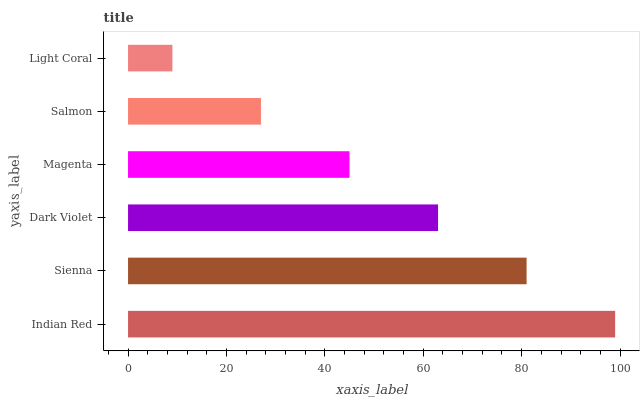Is Light Coral the minimum?
Answer yes or no. Yes. Is Indian Red the maximum?
Answer yes or no. Yes. Is Sienna the minimum?
Answer yes or no. No. Is Sienna the maximum?
Answer yes or no. No. Is Indian Red greater than Sienna?
Answer yes or no. Yes. Is Sienna less than Indian Red?
Answer yes or no. Yes. Is Sienna greater than Indian Red?
Answer yes or no. No. Is Indian Red less than Sienna?
Answer yes or no. No. Is Dark Violet the high median?
Answer yes or no. Yes. Is Magenta the low median?
Answer yes or no. Yes. Is Light Coral the high median?
Answer yes or no. No. Is Salmon the low median?
Answer yes or no. No. 